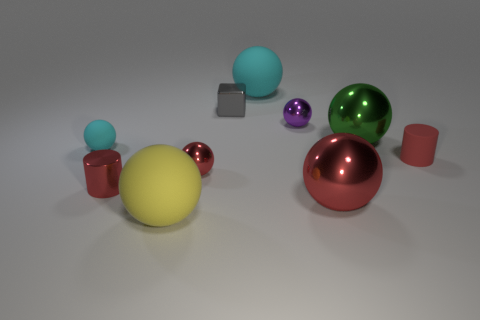Subtract all rubber balls. How many balls are left? 4 Subtract all cyan balls. How many balls are left? 5 Subtract 0 cyan cylinders. How many objects are left? 10 Subtract all blocks. How many objects are left? 9 Subtract 1 blocks. How many blocks are left? 0 Subtract all green spheres. Subtract all cyan cylinders. How many spheres are left? 6 Subtract all yellow cubes. How many cyan cylinders are left? 0 Subtract all green metallic things. Subtract all small metallic balls. How many objects are left? 7 Add 4 small metallic balls. How many small metallic balls are left? 6 Add 4 tiny brown cylinders. How many tiny brown cylinders exist? 4 